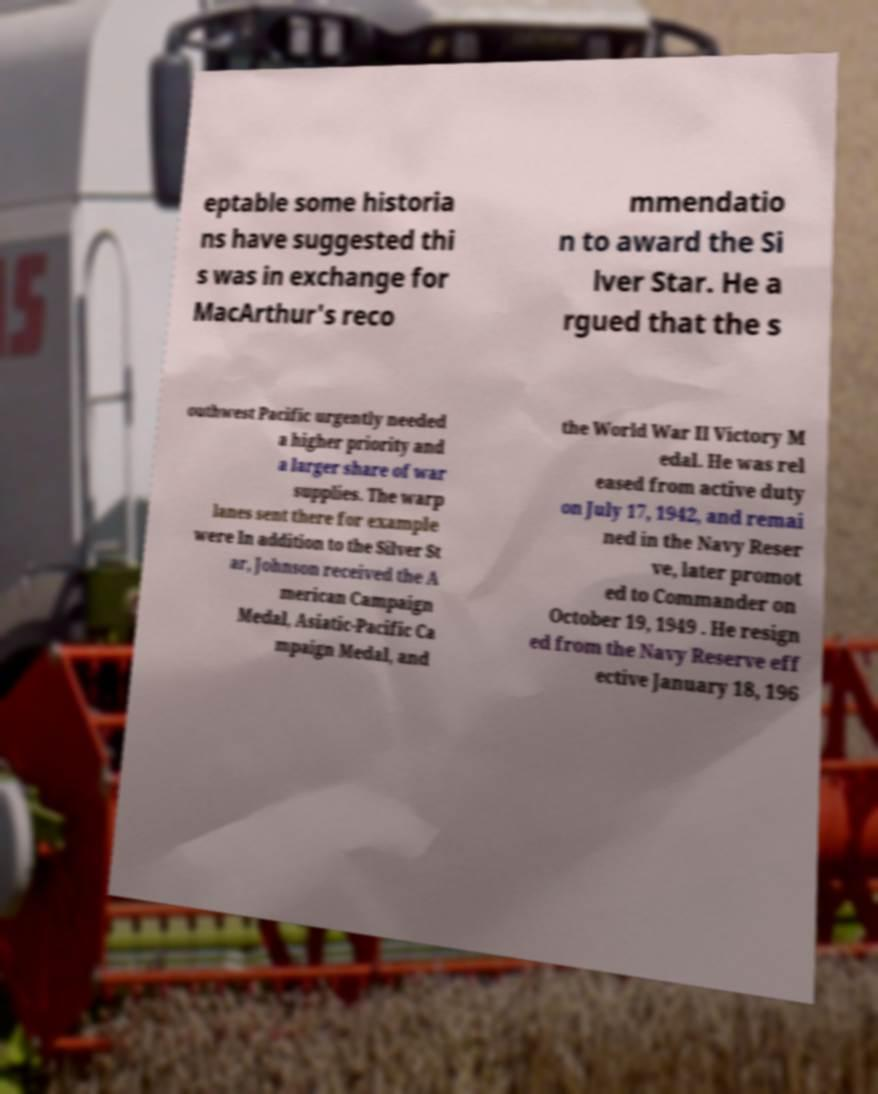Please read and relay the text visible in this image. What does it say? eptable some historia ns have suggested thi s was in exchange for MacArthur's reco mmendatio n to award the Si lver Star. He a rgued that the s outhwest Pacific urgently needed a higher priority and a larger share of war supplies. The warp lanes sent there for example were In addition to the Silver St ar, Johnson received the A merican Campaign Medal, Asiatic-Pacific Ca mpaign Medal, and the World War II Victory M edal. He was rel eased from active duty on July 17, 1942, and remai ned in the Navy Reser ve, later promot ed to Commander on October 19, 1949 . He resign ed from the Navy Reserve eff ective January 18, 196 